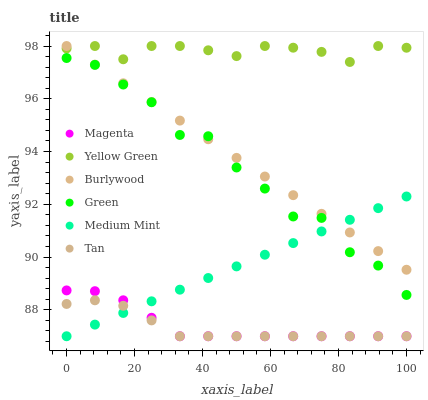Does Tan have the minimum area under the curve?
Answer yes or no. Yes. Does Yellow Green have the maximum area under the curve?
Answer yes or no. Yes. Does Burlywood have the minimum area under the curve?
Answer yes or no. No. Does Burlywood have the maximum area under the curve?
Answer yes or no. No. Is Medium Mint the smoothest?
Answer yes or no. Yes. Is Green the roughest?
Answer yes or no. Yes. Is Yellow Green the smoothest?
Answer yes or no. No. Is Yellow Green the roughest?
Answer yes or no. No. Does Medium Mint have the lowest value?
Answer yes or no. Yes. Does Burlywood have the lowest value?
Answer yes or no. No. Does Burlywood have the highest value?
Answer yes or no. Yes. Does Green have the highest value?
Answer yes or no. No. Is Tan less than Green?
Answer yes or no. Yes. Is Yellow Green greater than Medium Mint?
Answer yes or no. Yes. Does Tan intersect Magenta?
Answer yes or no. Yes. Is Tan less than Magenta?
Answer yes or no. No. Is Tan greater than Magenta?
Answer yes or no. No. Does Tan intersect Green?
Answer yes or no. No. 